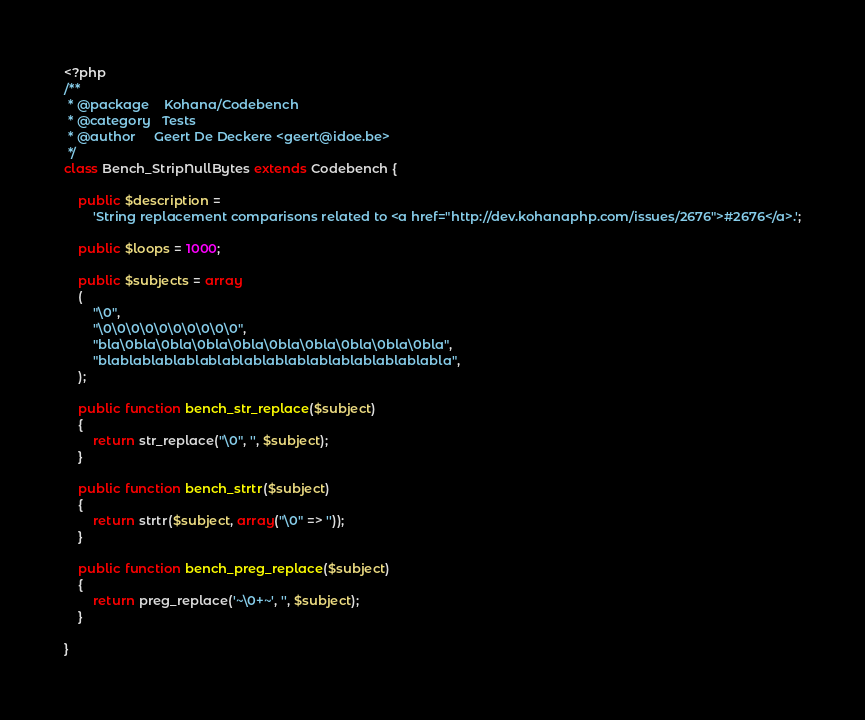Convert code to text. <code><loc_0><loc_0><loc_500><loc_500><_PHP_><?php
/**
 * @package    Kohana/Codebench
 * @category   Tests
 * @author     Geert De Deckere <geert@idoe.be>
 */
class Bench_StripNullBytes extends Codebench {

	public $description =
		'String replacement comparisons related to <a href="http://dev.kohanaphp.com/issues/2676">#2676</a>.';

	public $loops = 1000;

	public $subjects = array
	(
		"\0",
		"\0\0\0\0\0\0\0\0\0\0",
		"bla\0bla\0bla\0bla\0bla\0bla\0bla\0bla\0bla\0bla",
		"blablablablablablablablablablablablablablablabla",
	);

	public function bench_str_replace($subject)
	{
		return str_replace("\0", '', $subject);
	}

	public function bench_strtr($subject)
	{
		return strtr($subject, array("\0" => ''));
	}

	public function bench_preg_replace($subject)
	{
		return preg_replace('~\0+~', '', $subject);
	}

}</code> 